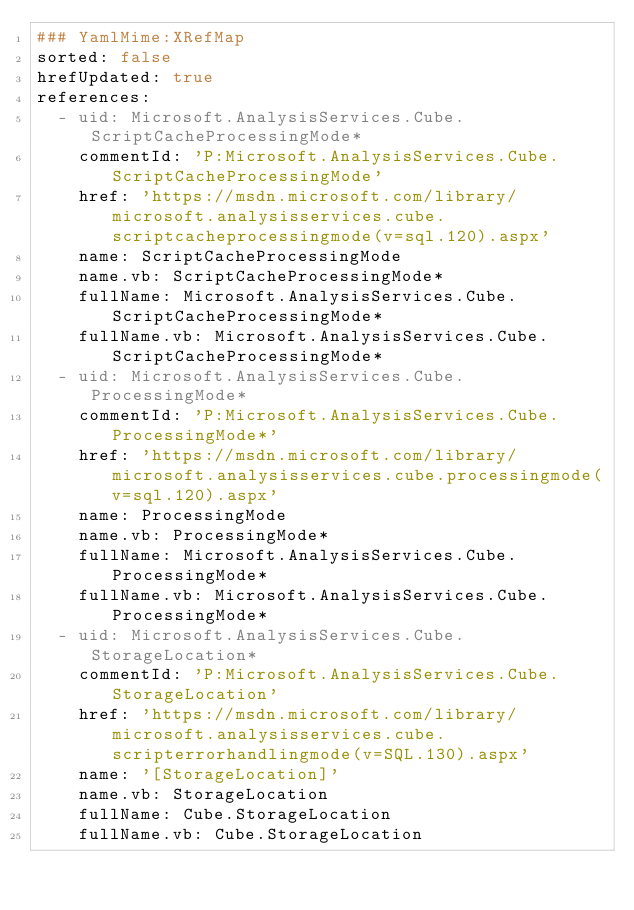<code> <loc_0><loc_0><loc_500><loc_500><_YAML_>### YamlMime:XRefMap
sorted: false
hrefUpdated: true
references:
  - uid: Microsoft.AnalysisServices.Cube.ScriptCacheProcessingMode*
    commentId: 'P:Microsoft.AnalysisServices.Cube.ScriptCacheProcessingMode'
    href: 'https://msdn.microsoft.com/library/microsoft.analysisservices.cube.scriptcacheprocessingmode(v=sql.120).aspx'
    name: ScriptCacheProcessingMode
    name.vb: ScriptCacheProcessingMode*
    fullName: Microsoft.AnalysisServices.Cube.ScriptCacheProcessingMode*
    fullName.vb: Microsoft.AnalysisServices.Cube.ScriptCacheProcessingMode*
  - uid: Microsoft.AnalysisServices.Cube.ProcessingMode*
    commentId: 'P:Microsoft.AnalysisServices.Cube.ProcessingMode*'
    href: 'https://msdn.microsoft.com/library/microsoft.analysisservices.cube.processingmode(v=sql.120).aspx'
    name: ProcessingMode
    name.vb: ProcessingMode*
    fullName: Microsoft.AnalysisServices.Cube.ProcessingMode*
    fullName.vb: Microsoft.AnalysisServices.Cube.ProcessingMode*
  - uid: Microsoft.AnalysisServices.Cube.StorageLocation*
    commentId: 'P:Microsoft.AnalysisServices.Cube.StorageLocation'
    href: 'https://msdn.microsoft.com/library/microsoft.analysisservices.cube.scripterrorhandlingmode(v=SQL.130).aspx'
    name: '[StorageLocation]'
    name.vb: StorageLocation
    fullName: Cube.StorageLocation
    fullName.vb: Cube.StorageLocation</code> 